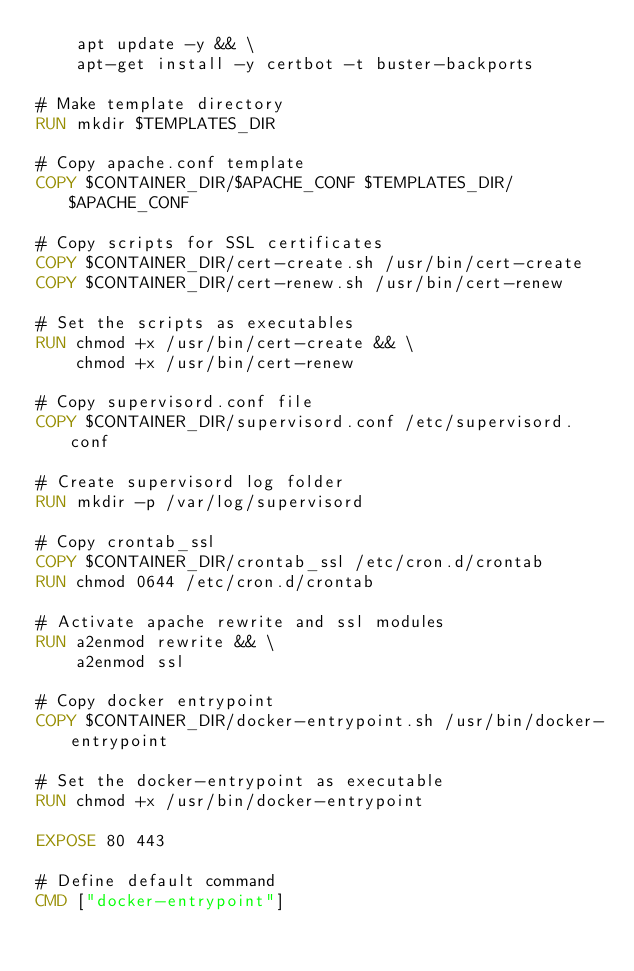Convert code to text. <code><loc_0><loc_0><loc_500><loc_500><_Dockerfile_>    apt update -y && \
    apt-get install -y certbot -t buster-backports

# Make template directory
RUN mkdir $TEMPLATES_DIR

# Copy apache.conf template
COPY $CONTAINER_DIR/$APACHE_CONF $TEMPLATES_DIR/$APACHE_CONF

# Copy scripts for SSL certificates
COPY $CONTAINER_DIR/cert-create.sh /usr/bin/cert-create
COPY $CONTAINER_DIR/cert-renew.sh /usr/bin/cert-renew

# Set the scripts as executables
RUN chmod +x /usr/bin/cert-create && \
    chmod +x /usr/bin/cert-renew

# Copy supervisord.conf file
COPY $CONTAINER_DIR/supervisord.conf /etc/supervisord.conf

# Create supervisord log folder
RUN mkdir -p /var/log/supervisord

# Copy crontab_ssl
COPY $CONTAINER_DIR/crontab_ssl /etc/cron.d/crontab
RUN chmod 0644 /etc/cron.d/crontab

# Activate apache rewrite and ssl modules
RUN a2enmod rewrite && \
    a2enmod ssl

# Copy docker entrypoint
COPY $CONTAINER_DIR/docker-entrypoint.sh /usr/bin/docker-entrypoint

# Set the docker-entrypoint as executable
RUN chmod +x /usr/bin/docker-entrypoint

EXPOSE 80 443

# Define default command
CMD ["docker-entrypoint"]</code> 